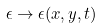<formula> <loc_0><loc_0><loc_500><loc_500>\epsilon \to \epsilon ( x , y , t )</formula> 